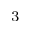<formula> <loc_0><loc_0><loc_500><loc_500>^ { 3 }</formula> 